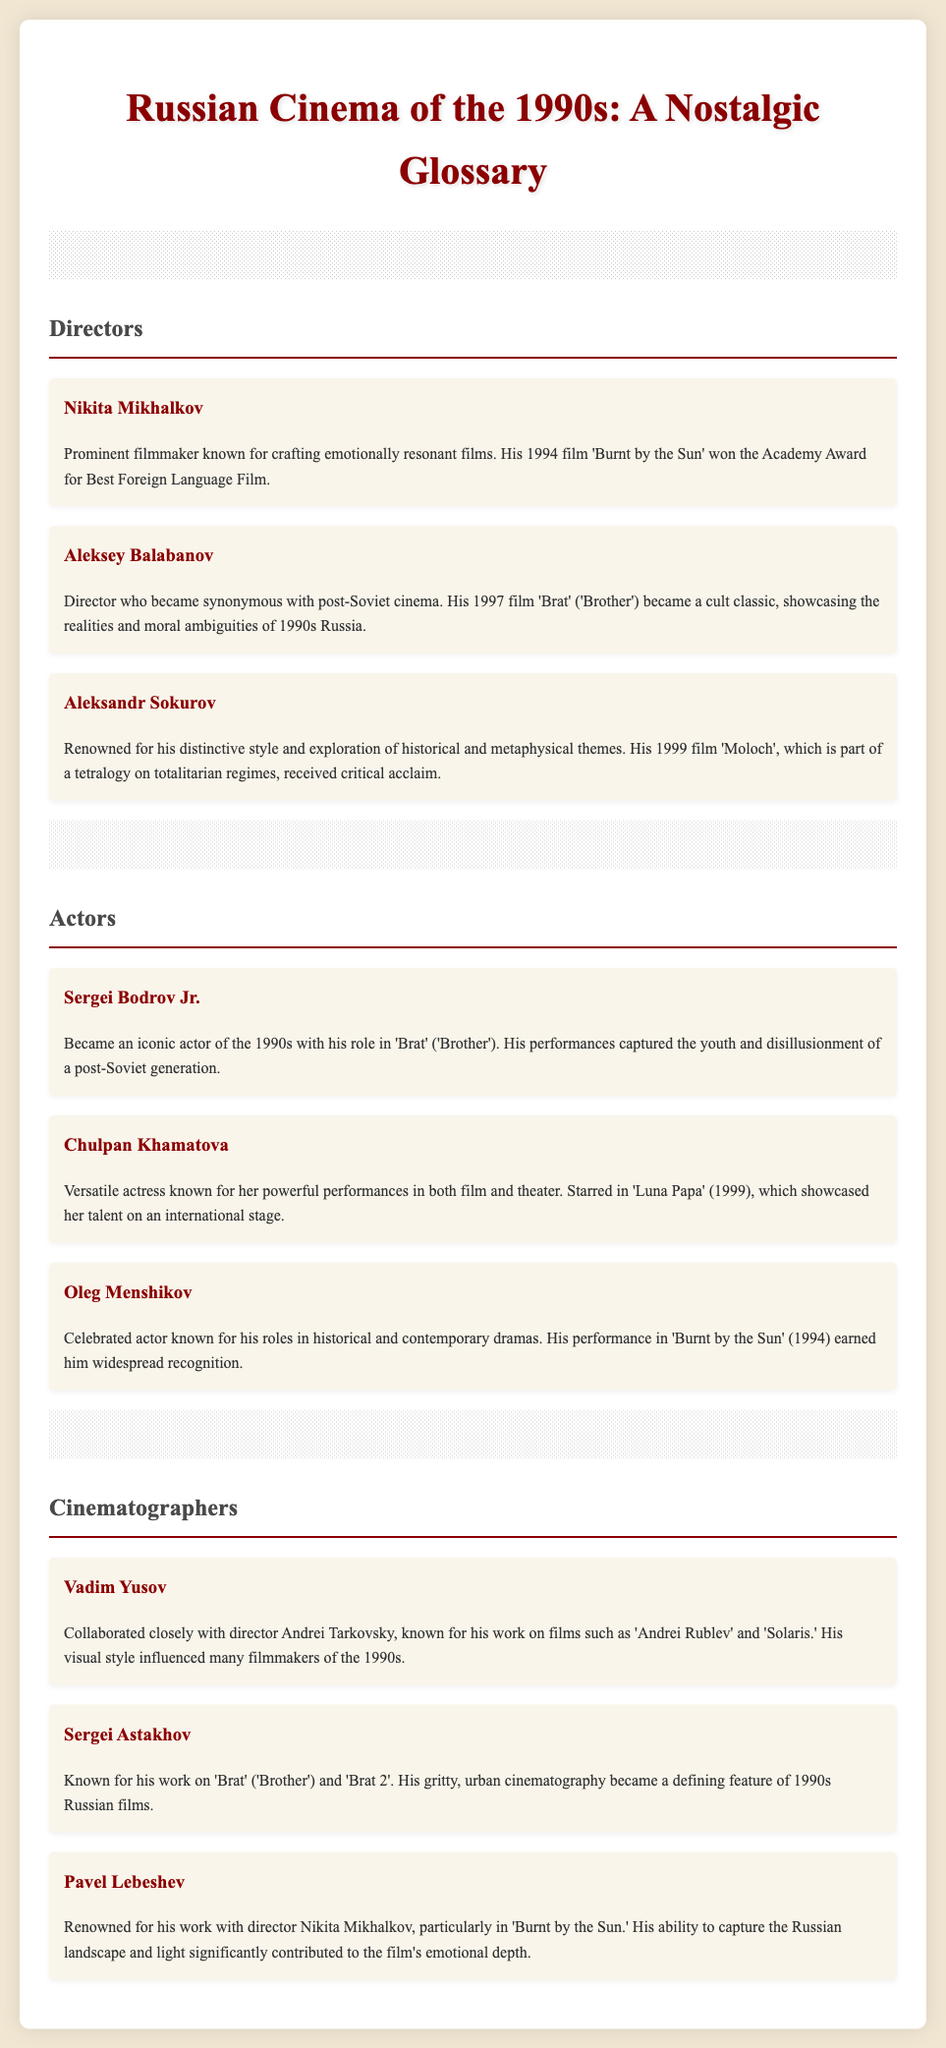What film won the Academy Award for Best Foreign Language Film in 1994? The document states that 'Burnt by the Sun' won the Academy Award for Best Foreign Language Film in 1994.
Answer: 'Burnt by the Sun' Who directed the cult classic 'Brat'? Aleksey Balabanov is noted as the director of 'Brat' ('Brother') in the document.
Answer: Aleksey Balabanov Which actress starred in 'Luna Papa' (1999)? Chulpan Khamatova is mentioned as starring in 'Luna Papa' (1999).
Answer: Chulpan Khamatova What is the film 'Moloch' about? 'Moloch' is part of a tetralogy on totalitarian regimes, as described in the document.
Answer: Totalitarian regimes Which cinematographer is known for working on 'Andrei Rublev' and 'Solaris'? The document highlights Vadim Yusov for his collaborations on those films.
Answer: Vadim Yusov What year was 'Brat' released? The document states that 'Brat' was released in 1997.
Answer: 1997 Which director is renowned for his visual style influencing 1990s filmmakers? The document identifies Aleksandr Sokurov for his distinctive style and themes.
Answer: Aleksandr Sokurov Who collaborated closely with director Nikita Mikhalkov? Pavel Lebeshev is mentioned as having worked with Mikhalkov.
Answer: Pavel Lebeshev 